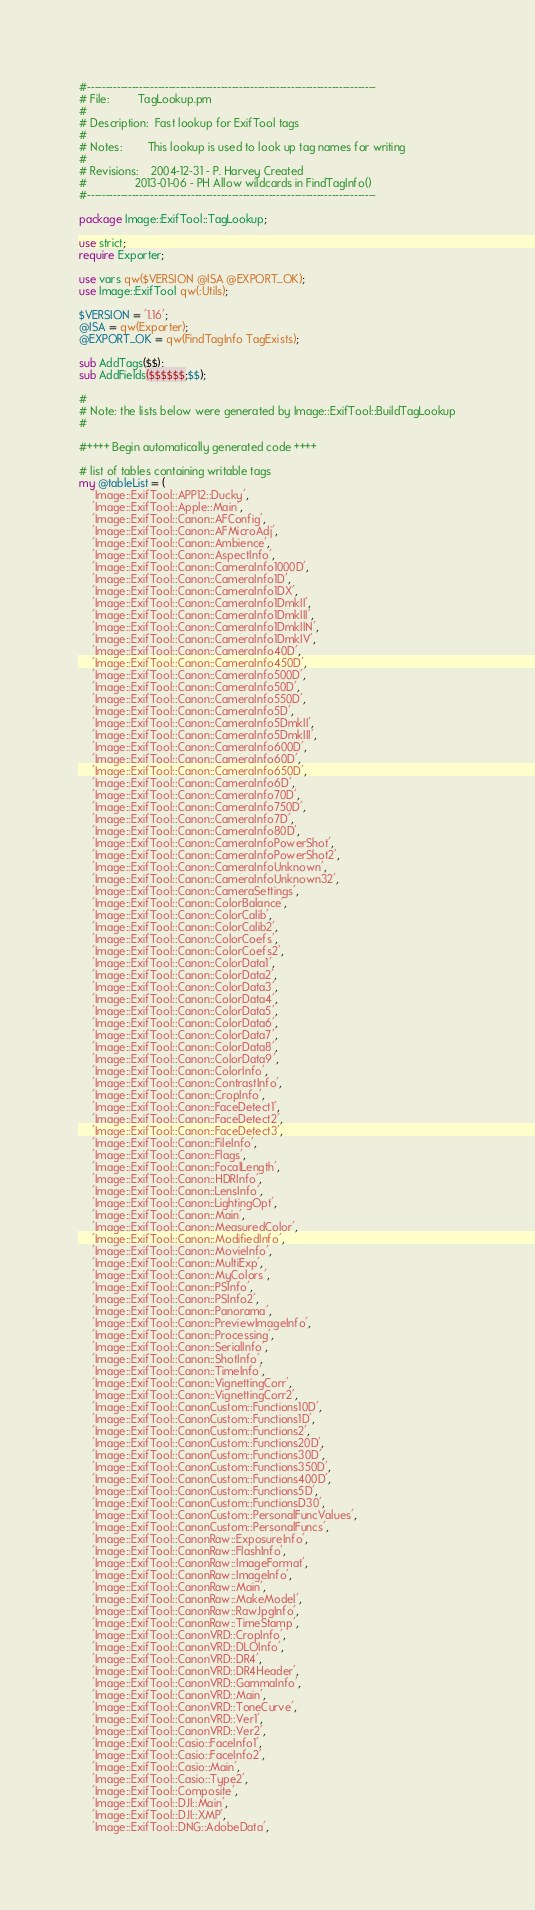<code> <loc_0><loc_0><loc_500><loc_500><_Perl_>#------------------------------------------------------------------------------
# File:         TagLookup.pm
#
# Description:  Fast lookup for ExifTool tags
#
# Notes:        This lookup is used to look up tag names for writing
#
# Revisions:    2004-12-31 - P. Harvey Created
#               2013-01-06 - PH Allow wildcards in FindTagInfo()
#------------------------------------------------------------------------------

package Image::ExifTool::TagLookup;

use strict;
require Exporter;

use vars qw($VERSION @ISA @EXPORT_OK);
use Image::ExifTool qw(:Utils);

$VERSION = '1.16';
@ISA = qw(Exporter);
@EXPORT_OK = qw(FindTagInfo TagExists);

sub AddTags($$);
sub AddFields($$$$$$;$$);

#
# Note: the lists below were generated by Image::ExifTool::BuildTagLookup
#

#++++ Begin automatically generated code ++++

# list of tables containing writable tags
my @tableList = (
	'Image::ExifTool::APP12::Ducky',
	'Image::ExifTool::Apple::Main',
	'Image::ExifTool::Canon::AFConfig',
	'Image::ExifTool::Canon::AFMicroAdj',
	'Image::ExifTool::Canon::Ambience',
	'Image::ExifTool::Canon::AspectInfo',
	'Image::ExifTool::Canon::CameraInfo1000D',
	'Image::ExifTool::Canon::CameraInfo1D',
	'Image::ExifTool::Canon::CameraInfo1DX',
	'Image::ExifTool::Canon::CameraInfo1DmkII',
	'Image::ExifTool::Canon::CameraInfo1DmkIII',
	'Image::ExifTool::Canon::CameraInfo1DmkIIN',
	'Image::ExifTool::Canon::CameraInfo1DmkIV',
	'Image::ExifTool::Canon::CameraInfo40D',
	'Image::ExifTool::Canon::CameraInfo450D',
	'Image::ExifTool::Canon::CameraInfo500D',
	'Image::ExifTool::Canon::CameraInfo50D',
	'Image::ExifTool::Canon::CameraInfo550D',
	'Image::ExifTool::Canon::CameraInfo5D',
	'Image::ExifTool::Canon::CameraInfo5DmkII',
	'Image::ExifTool::Canon::CameraInfo5DmkIII',
	'Image::ExifTool::Canon::CameraInfo600D',
	'Image::ExifTool::Canon::CameraInfo60D',
	'Image::ExifTool::Canon::CameraInfo650D',
	'Image::ExifTool::Canon::CameraInfo6D',
	'Image::ExifTool::Canon::CameraInfo70D',
	'Image::ExifTool::Canon::CameraInfo750D',
	'Image::ExifTool::Canon::CameraInfo7D',
	'Image::ExifTool::Canon::CameraInfo80D',
	'Image::ExifTool::Canon::CameraInfoPowerShot',
	'Image::ExifTool::Canon::CameraInfoPowerShot2',
	'Image::ExifTool::Canon::CameraInfoUnknown',
	'Image::ExifTool::Canon::CameraInfoUnknown32',
	'Image::ExifTool::Canon::CameraSettings',
	'Image::ExifTool::Canon::ColorBalance',
	'Image::ExifTool::Canon::ColorCalib',
	'Image::ExifTool::Canon::ColorCalib2',
	'Image::ExifTool::Canon::ColorCoefs',
	'Image::ExifTool::Canon::ColorCoefs2',
	'Image::ExifTool::Canon::ColorData1',
	'Image::ExifTool::Canon::ColorData2',
	'Image::ExifTool::Canon::ColorData3',
	'Image::ExifTool::Canon::ColorData4',
	'Image::ExifTool::Canon::ColorData5',
	'Image::ExifTool::Canon::ColorData6',
	'Image::ExifTool::Canon::ColorData7',
	'Image::ExifTool::Canon::ColorData8',
	'Image::ExifTool::Canon::ColorData9',
	'Image::ExifTool::Canon::ColorInfo',
	'Image::ExifTool::Canon::ContrastInfo',
	'Image::ExifTool::Canon::CropInfo',
	'Image::ExifTool::Canon::FaceDetect1',
	'Image::ExifTool::Canon::FaceDetect2',
	'Image::ExifTool::Canon::FaceDetect3',
	'Image::ExifTool::Canon::FileInfo',
	'Image::ExifTool::Canon::Flags',
	'Image::ExifTool::Canon::FocalLength',
	'Image::ExifTool::Canon::HDRInfo',
	'Image::ExifTool::Canon::LensInfo',
	'Image::ExifTool::Canon::LightingOpt',
	'Image::ExifTool::Canon::Main',
	'Image::ExifTool::Canon::MeasuredColor',
	'Image::ExifTool::Canon::ModifiedInfo',
	'Image::ExifTool::Canon::MovieInfo',
	'Image::ExifTool::Canon::MultiExp',
	'Image::ExifTool::Canon::MyColors',
	'Image::ExifTool::Canon::PSInfo',
	'Image::ExifTool::Canon::PSInfo2',
	'Image::ExifTool::Canon::Panorama',
	'Image::ExifTool::Canon::PreviewImageInfo',
	'Image::ExifTool::Canon::Processing',
	'Image::ExifTool::Canon::SerialInfo',
	'Image::ExifTool::Canon::ShotInfo',
	'Image::ExifTool::Canon::TimeInfo',
	'Image::ExifTool::Canon::VignettingCorr',
	'Image::ExifTool::Canon::VignettingCorr2',
	'Image::ExifTool::CanonCustom::Functions10D',
	'Image::ExifTool::CanonCustom::Functions1D',
	'Image::ExifTool::CanonCustom::Functions2',
	'Image::ExifTool::CanonCustom::Functions20D',
	'Image::ExifTool::CanonCustom::Functions30D',
	'Image::ExifTool::CanonCustom::Functions350D',
	'Image::ExifTool::CanonCustom::Functions400D',
	'Image::ExifTool::CanonCustom::Functions5D',
	'Image::ExifTool::CanonCustom::FunctionsD30',
	'Image::ExifTool::CanonCustom::PersonalFuncValues',
	'Image::ExifTool::CanonCustom::PersonalFuncs',
	'Image::ExifTool::CanonRaw::ExposureInfo',
	'Image::ExifTool::CanonRaw::FlashInfo',
	'Image::ExifTool::CanonRaw::ImageFormat',
	'Image::ExifTool::CanonRaw::ImageInfo',
	'Image::ExifTool::CanonRaw::Main',
	'Image::ExifTool::CanonRaw::MakeModel',
	'Image::ExifTool::CanonRaw::RawJpgInfo',
	'Image::ExifTool::CanonRaw::TimeStamp',
	'Image::ExifTool::CanonVRD::CropInfo',
	'Image::ExifTool::CanonVRD::DLOInfo',
	'Image::ExifTool::CanonVRD::DR4',
	'Image::ExifTool::CanonVRD::DR4Header',
	'Image::ExifTool::CanonVRD::GammaInfo',
	'Image::ExifTool::CanonVRD::Main',
	'Image::ExifTool::CanonVRD::ToneCurve',
	'Image::ExifTool::CanonVRD::Ver1',
	'Image::ExifTool::CanonVRD::Ver2',
	'Image::ExifTool::Casio::FaceInfo1',
	'Image::ExifTool::Casio::FaceInfo2',
	'Image::ExifTool::Casio::Main',
	'Image::ExifTool::Casio::Type2',
	'Image::ExifTool::Composite',
	'Image::ExifTool::DJI::Main',
	'Image::ExifTool::DJI::XMP',
	'Image::ExifTool::DNG::AdobeData',</code> 